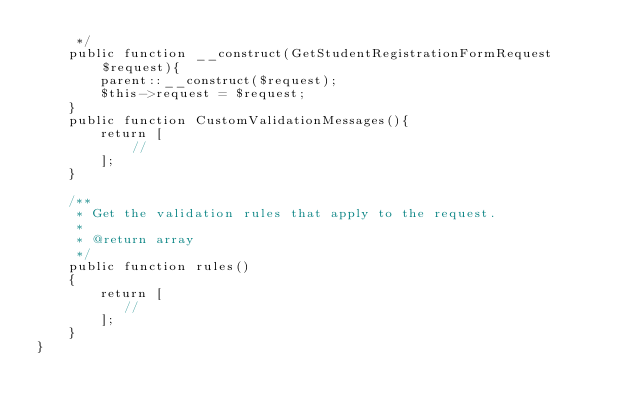Convert code to text. <code><loc_0><loc_0><loc_500><loc_500><_PHP_>     */
    public function __construct(GetStudentRegistrationFormRequest $request){
        parent::__construct($request);
        $this->request = $request;
    }
    public function CustomValidationMessages(){
        return [
            //
        ];
    }

    /**
     * Get the validation rules that apply to the request.
     *
     * @return array
     */
    public function rules()
    {
        return [
           //
        ];
    }
}</code> 